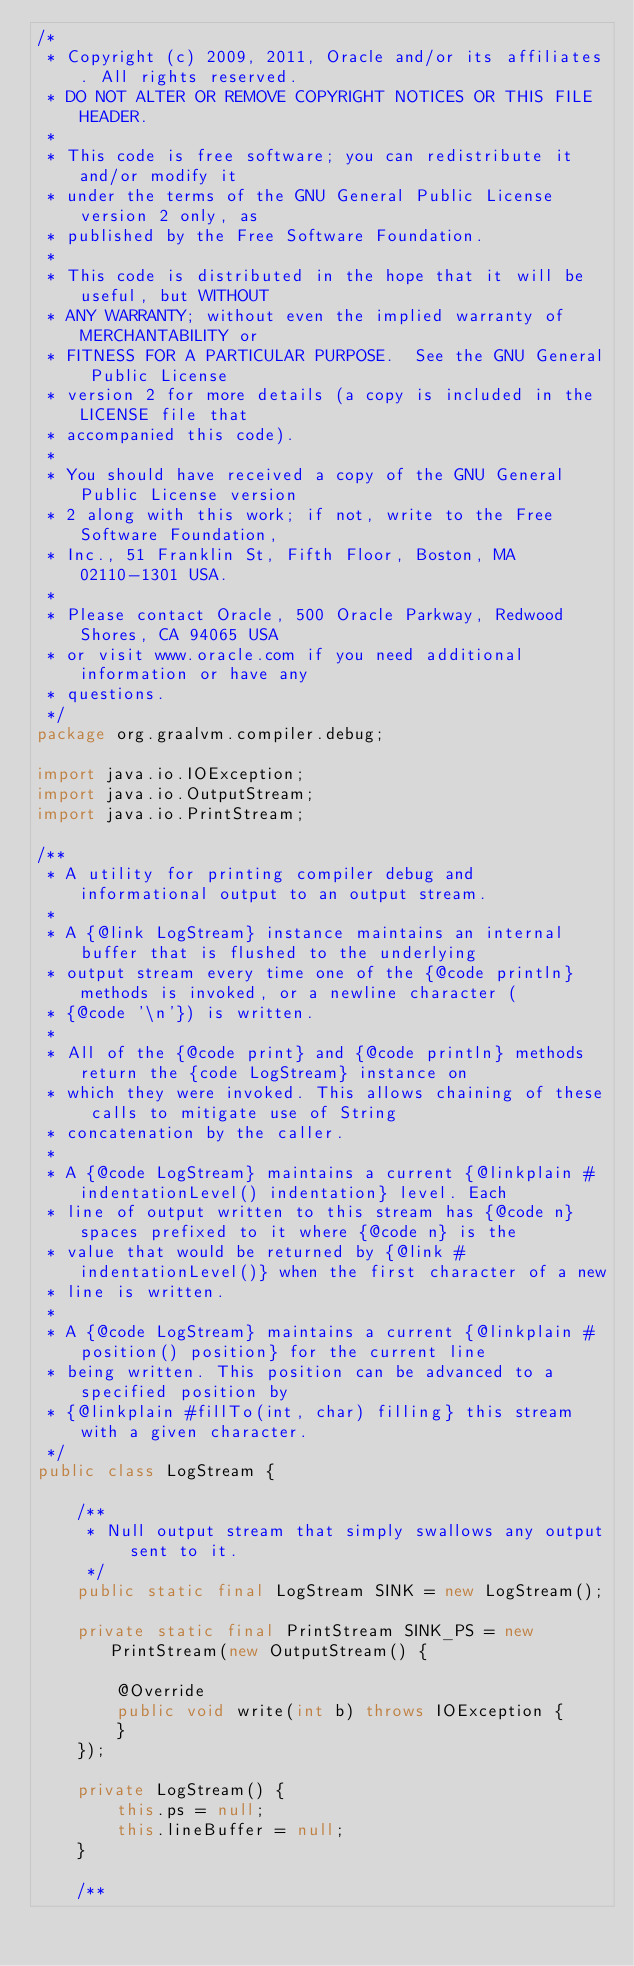Convert code to text. <code><loc_0><loc_0><loc_500><loc_500><_Java_>/*
 * Copyright (c) 2009, 2011, Oracle and/or its affiliates. All rights reserved.
 * DO NOT ALTER OR REMOVE COPYRIGHT NOTICES OR THIS FILE HEADER.
 *
 * This code is free software; you can redistribute it and/or modify it
 * under the terms of the GNU General Public License version 2 only, as
 * published by the Free Software Foundation.
 *
 * This code is distributed in the hope that it will be useful, but WITHOUT
 * ANY WARRANTY; without even the implied warranty of MERCHANTABILITY or
 * FITNESS FOR A PARTICULAR PURPOSE.  See the GNU General Public License
 * version 2 for more details (a copy is included in the LICENSE file that
 * accompanied this code).
 *
 * You should have received a copy of the GNU General Public License version
 * 2 along with this work; if not, write to the Free Software Foundation,
 * Inc., 51 Franklin St, Fifth Floor, Boston, MA 02110-1301 USA.
 *
 * Please contact Oracle, 500 Oracle Parkway, Redwood Shores, CA 94065 USA
 * or visit www.oracle.com if you need additional information or have any
 * questions.
 */
package org.graalvm.compiler.debug;

import java.io.IOException;
import java.io.OutputStream;
import java.io.PrintStream;

/**
 * A utility for printing compiler debug and informational output to an output stream.
 *
 * A {@link LogStream} instance maintains an internal buffer that is flushed to the underlying
 * output stream every time one of the {@code println} methods is invoked, or a newline character (
 * {@code '\n'}) is written.
 *
 * All of the {@code print} and {@code println} methods return the {code LogStream} instance on
 * which they were invoked. This allows chaining of these calls to mitigate use of String
 * concatenation by the caller.
 *
 * A {@code LogStream} maintains a current {@linkplain #indentationLevel() indentation} level. Each
 * line of output written to this stream has {@code n} spaces prefixed to it where {@code n} is the
 * value that would be returned by {@link #indentationLevel()} when the first character of a new
 * line is written.
 *
 * A {@code LogStream} maintains a current {@linkplain #position() position} for the current line
 * being written. This position can be advanced to a specified position by
 * {@linkplain #fillTo(int, char) filling} this stream with a given character.
 */
public class LogStream {

    /**
     * Null output stream that simply swallows any output sent to it.
     */
    public static final LogStream SINK = new LogStream();

    private static final PrintStream SINK_PS = new PrintStream(new OutputStream() {

        @Override
        public void write(int b) throws IOException {
        }
    });

    private LogStream() {
        this.ps = null;
        this.lineBuffer = null;
    }

    /**</code> 